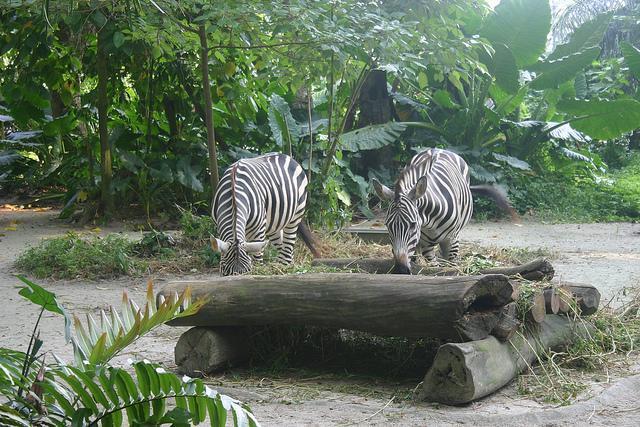How many animals?
Give a very brief answer. 2. How many zebras are there?
Give a very brief answer. 2. 